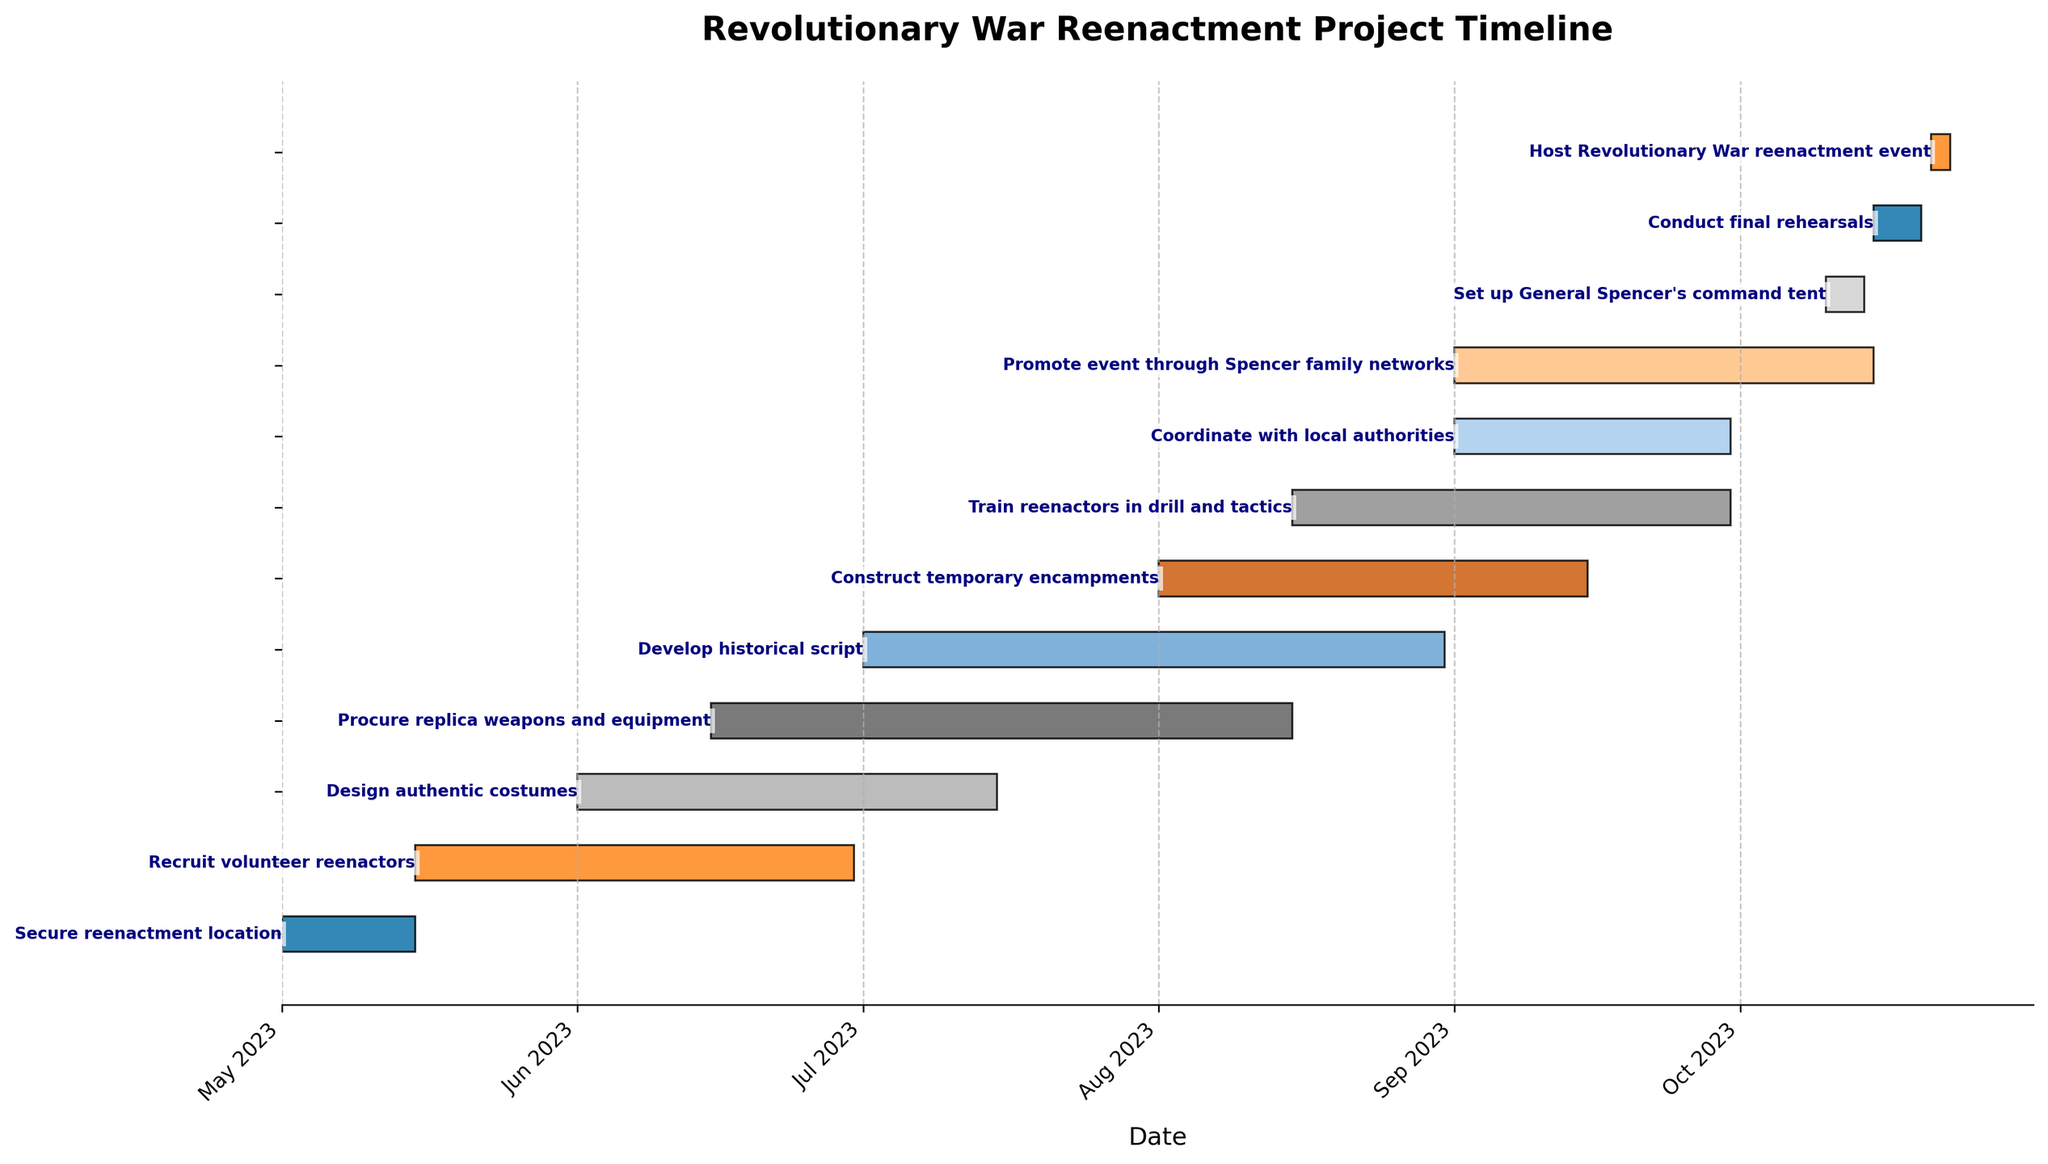What is the title of the Gantt Chart? The title of the chart is the text shown at the very top of the figure. By referring to the text at the top, we can identify it as the title.
Answer: Revolutionary War Reenactment Project Timeline How many tasks are there in the project timeline? Count the number of bars or tasks listed in the Gantt chart. Each bar represents one task.
Answer: 12 Which task starts first? Look for the task that has a bar starting at the earliest date on the x-axis. This identifies the first task in the sequence.
Answer: Secure reenactment location Which task has the longest duration? Compare the lengths of the bars to determine which one is the longest. This indicates the task with the longest duration.
Answer: Procure replica weapons and equipment When does the task "Train reenactors in drill and tactics" start and end? Locate the bar labeled "Train reenactors in drill and tactics" and check its start and end points on the x-axis to identify the respective dates.
Answer: Starts on 2023-08-15 and ends on 2023-09-30 How many tasks overlap with "Construct temporary encampments"? Identify the start and end dates of "Construct temporary encampments" and count the number of bars that overlap with this time range.
Answer: 4 Which task is scheduled to end last? Look for the task that has its end date closest to the rightmost side of the x-axis. This indicates the task that ends last.
Answer: Host Revolutionary War reenactment event What is the time gap between the end of "Secure reenactment location" and the start of "Recruit volunteer reenactors"? Calculate the number of days between the end date of "Secure reenactment location" and the start date of "Recruit volunteer reenactors."
Answer: 0 days Which two tasks have an exact overlap in terms of their duration? Identify pairs of tasks that have bars starting and ending on the same dates. This indicates tasks with exact overlapping durations.
Answer: Coordinate with local authorities and Promote event through Spencer family networks What is the combined duration of "Develop historical script" and "Construct temporary encampments"? Add the duration of both tasks by referring to their individual lengths on the x-axis. Combine the number of days they each span.
Answer: 106 days 